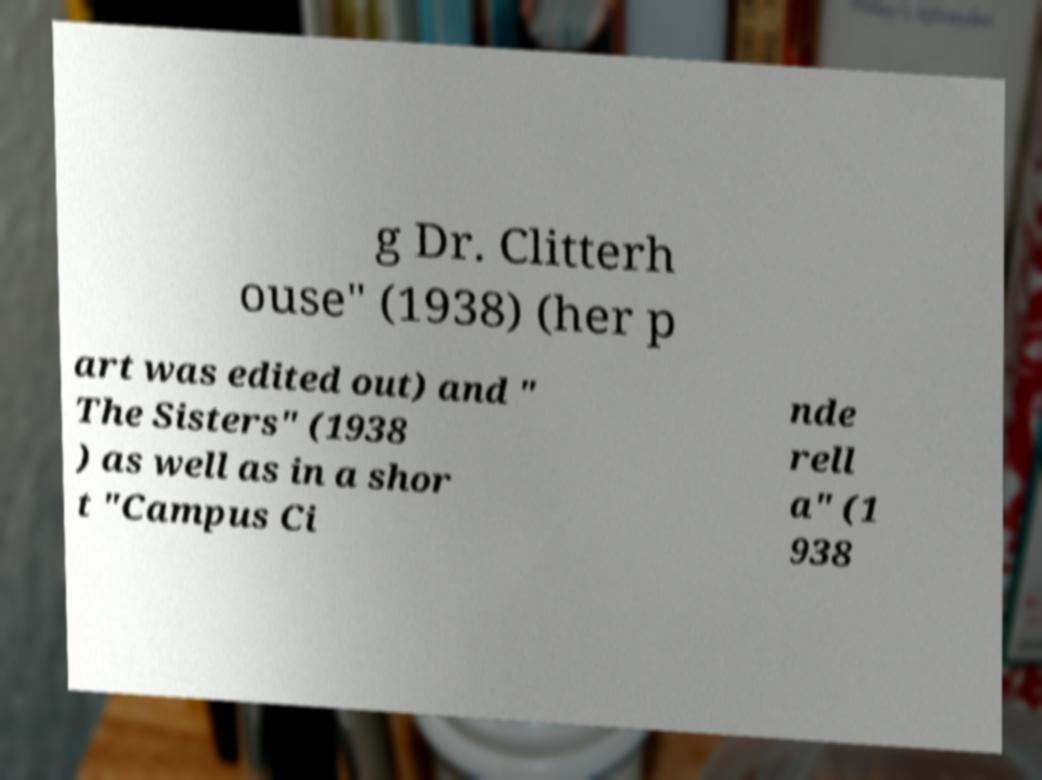What messages or text are displayed in this image? I need them in a readable, typed format. g Dr. Clitterh ouse" (1938) (her p art was edited out) and " The Sisters" (1938 ) as well as in a shor t "Campus Ci nde rell a" (1 938 